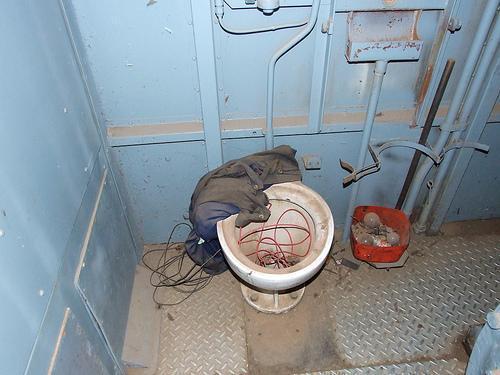How many toilets are shown?
Give a very brief answer. 1. 